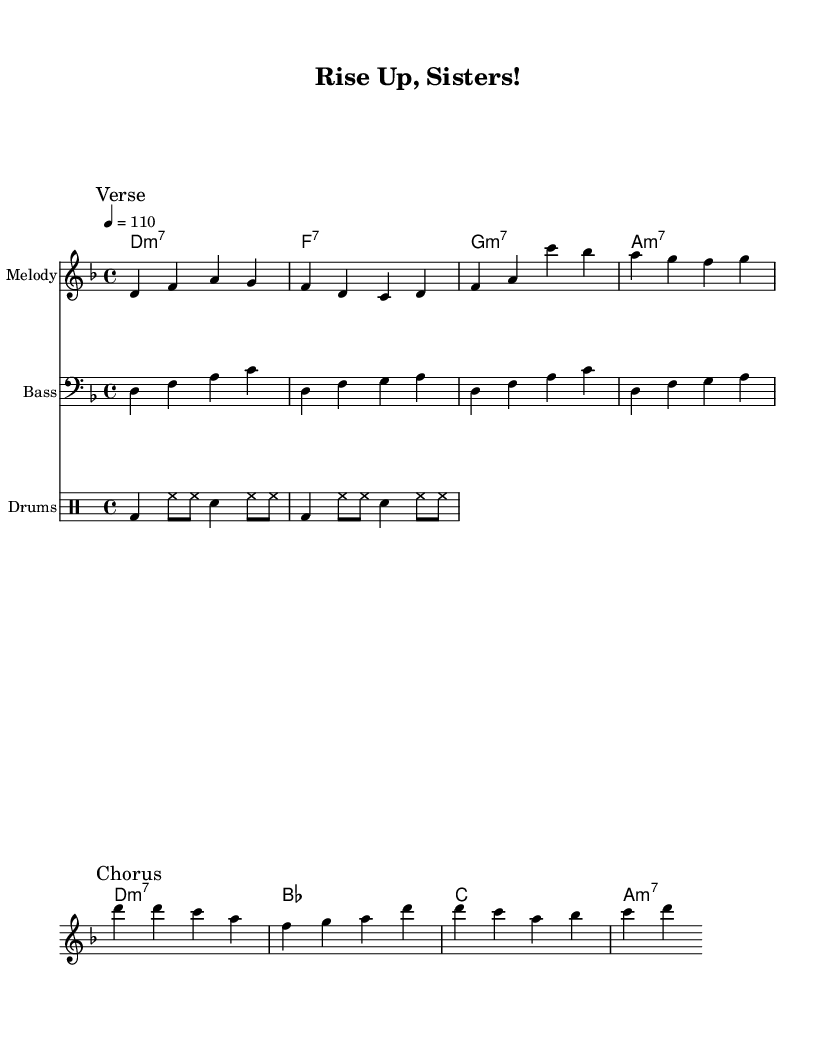What is the key signature of this music? The key signature is indicated at the beginning of the score with one flat, which signifies that it is in D minor.
Answer: D minor What is the time signature of this score? The time signature is shown at the beginning of the music as 4/4, which means there are four beats in each measure and the quarter note gets one beat.
Answer: 4/4 What is the tempo marking for this piece? The tempo is indicated at the start with a metronome marking of 110, meaning there are 110 beats per minute for the performance of this music.
Answer: 110 How many measures are there in the chorus? Counting from the melody and the corresponding lyrics in the chorus section, there are a total of four measures in the chorus.
Answer: 4 What type of chord follows the D minor chord in the chord progression? The chord that follows the D minor chord in the progression is an F major seventh chord as indicated in the score.
Answer: F7 What instrument plays the bass line in this score? The bass line is written on a staff that is specifically labeled for bass instruments, indicating that it is intended for a bass guitar or double bass.
Answer: Bass What is the primary theme celebrated in this funk anthem? The lyrics of the anthem focus on women's empowerment and achievements, highlighting themes of breaking barriers and shining brightly in society.
Answer: Women's empowerment 